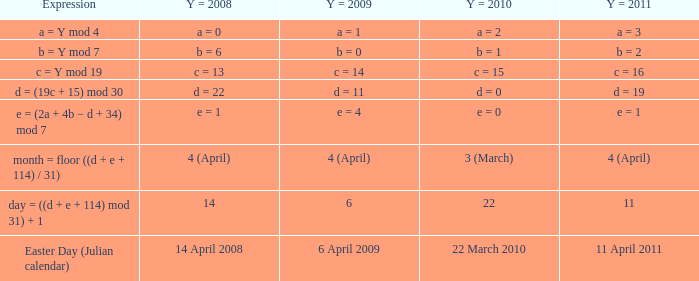Given that y = 2009 equates to april 6, 2009, what date does y = 2011 represent? 11 April 2011. 